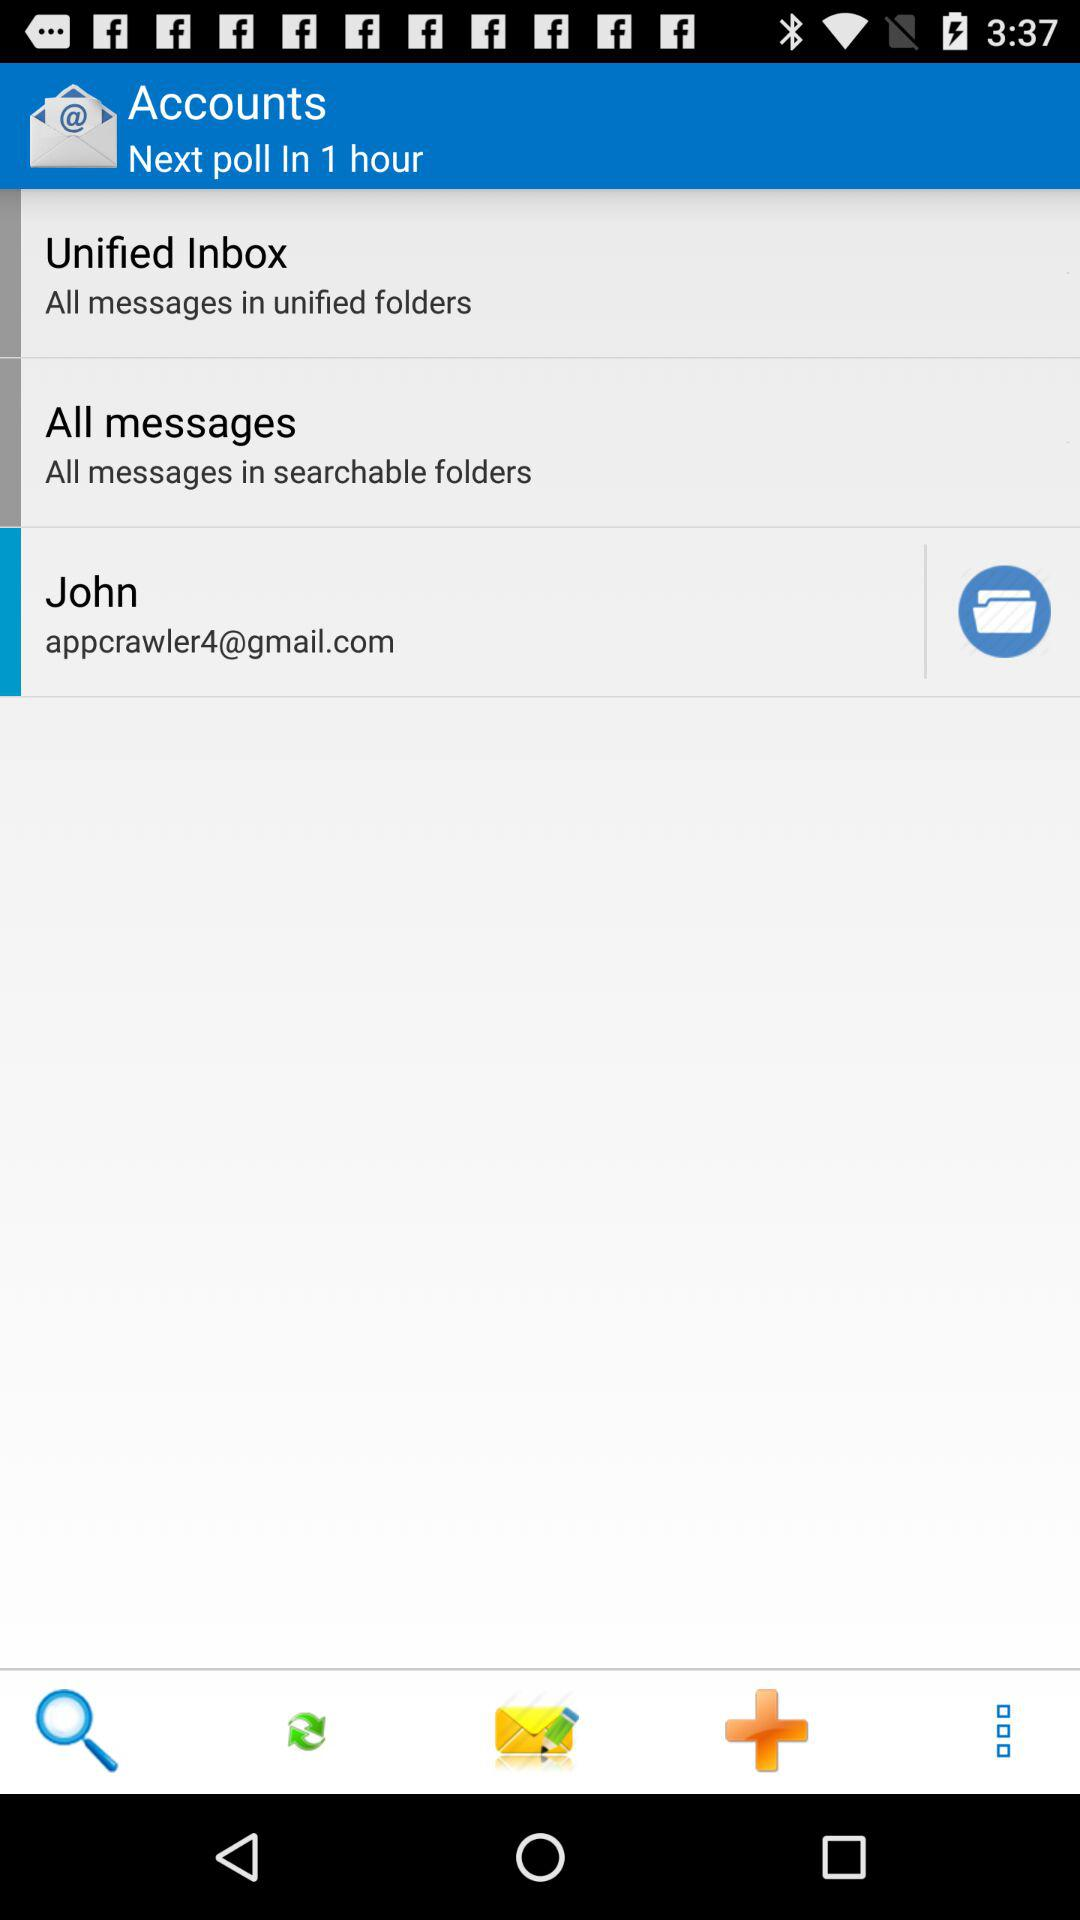When is the next poll? The next poll is in 1 hour. 